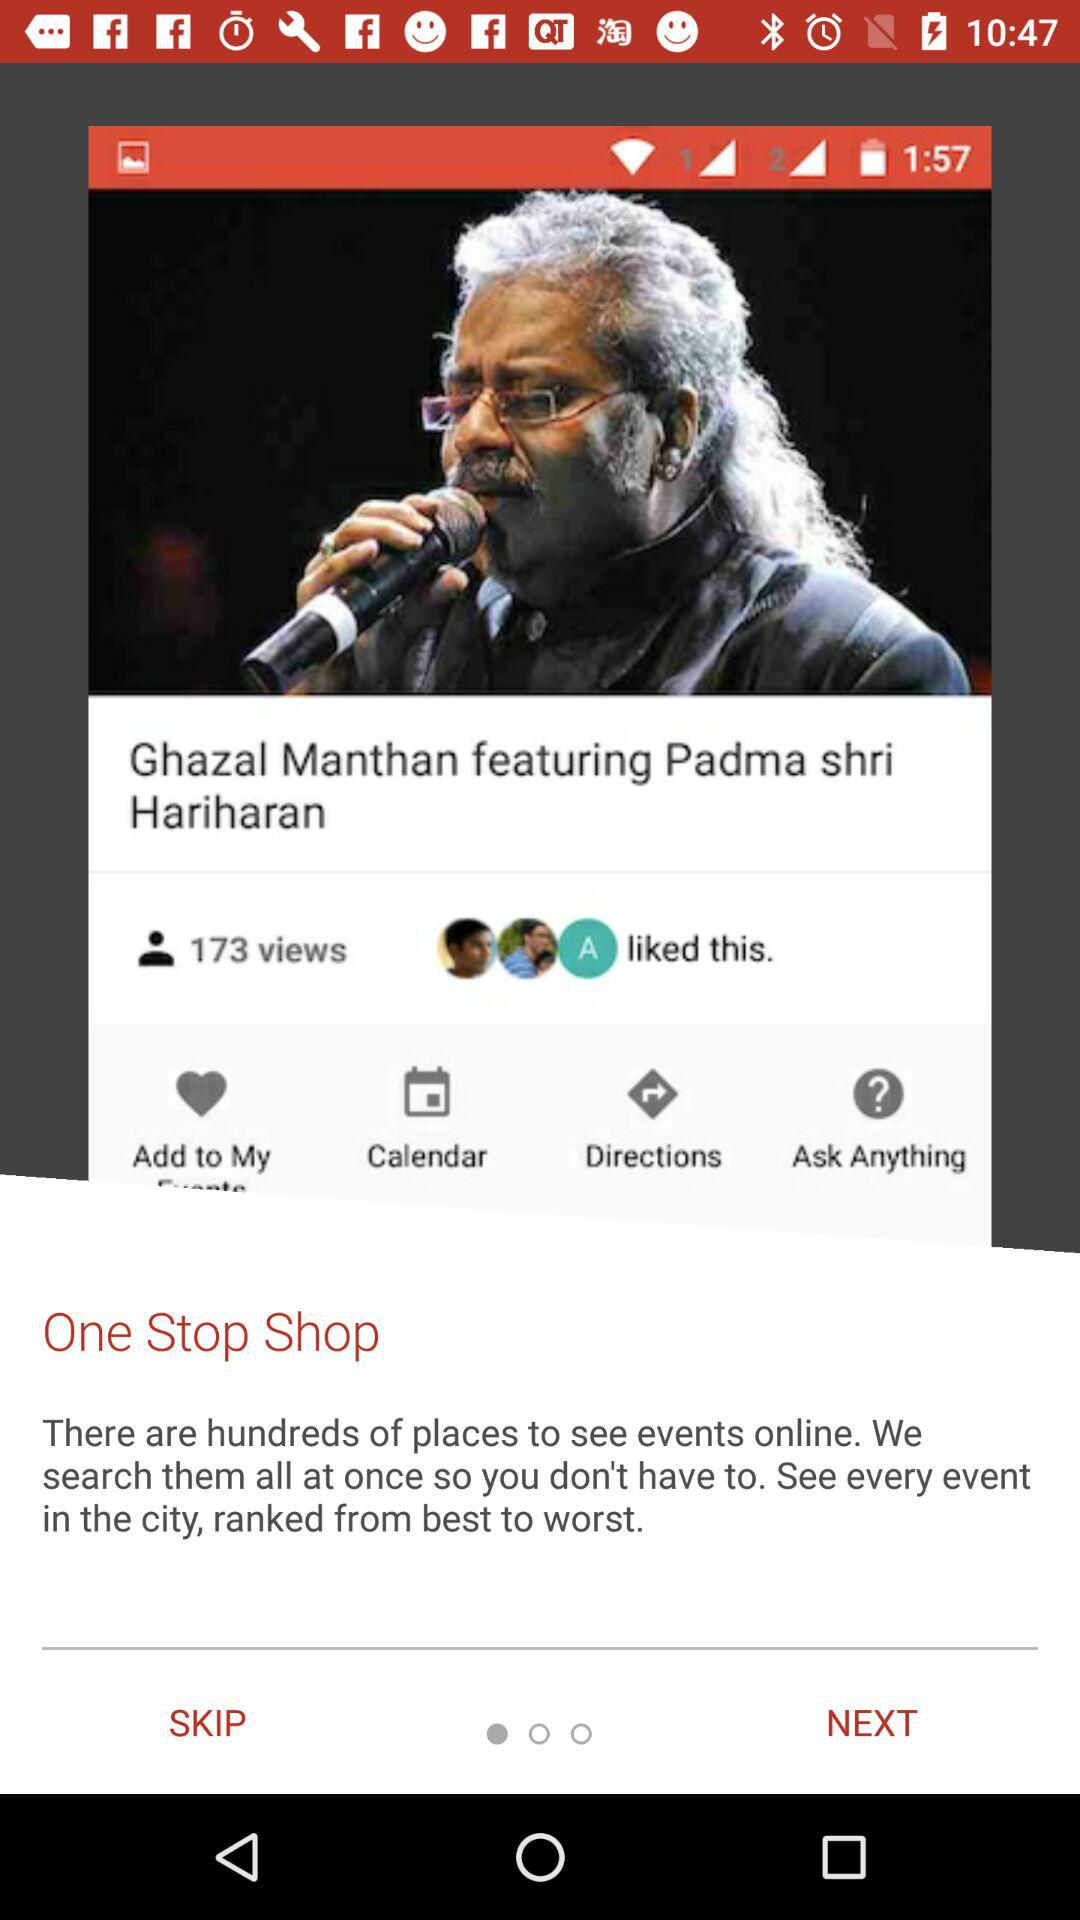How many total views did the post get? The post got 173 views. 